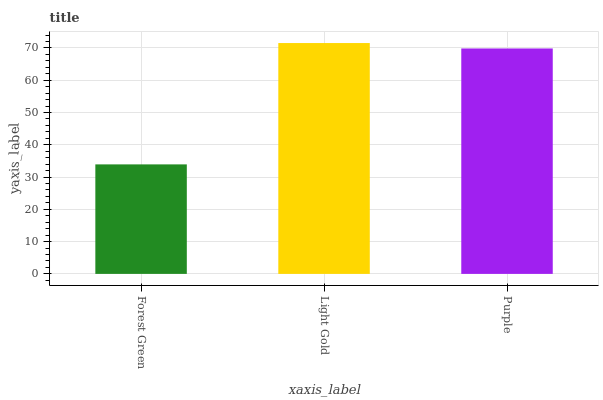Is Forest Green the minimum?
Answer yes or no. Yes. Is Light Gold the maximum?
Answer yes or no. Yes. Is Purple the minimum?
Answer yes or no. No. Is Purple the maximum?
Answer yes or no. No. Is Light Gold greater than Purple?
Answer yes or no. Yes. Is Purple less than Light Gold?
Answer yes or no. Yes. Is Purple greater than Light Gold?
Answer yes or no. No. Is Light Gold less than Purple?
Answer yes or no. No. Is Purple the high median?
Answer yes or no. Yes. Is Purple the low median?
Answer yes or no. Yes. Is Forest Green the high median?
Answer yes or no. No. Is Forest Green the low median?
Answer yes or no. No. 